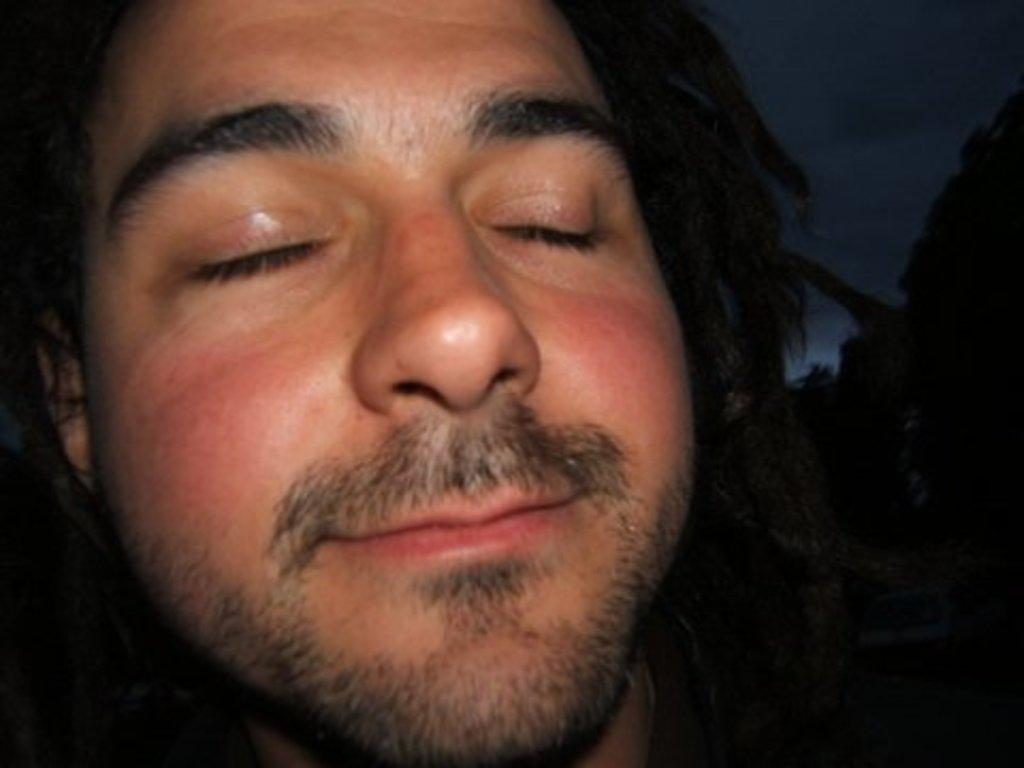Who is present in the image? There is a man in the image. What is the man doing with his eyes? The man's eyes are closed. What expression does the man have on his face? The man is smiling. What can be seen on the right side of the image? There is a black object on the right side of the image. How would you describe the overall lighting in the image? The background of the image is dark. How many zippers are visible on the man's hands in the image? There are no zippers visible on the man's hands in the image. How long does it take for the man to smile in the image? The image is a still photograph, so the man's smile is not a matter of time or duration. 